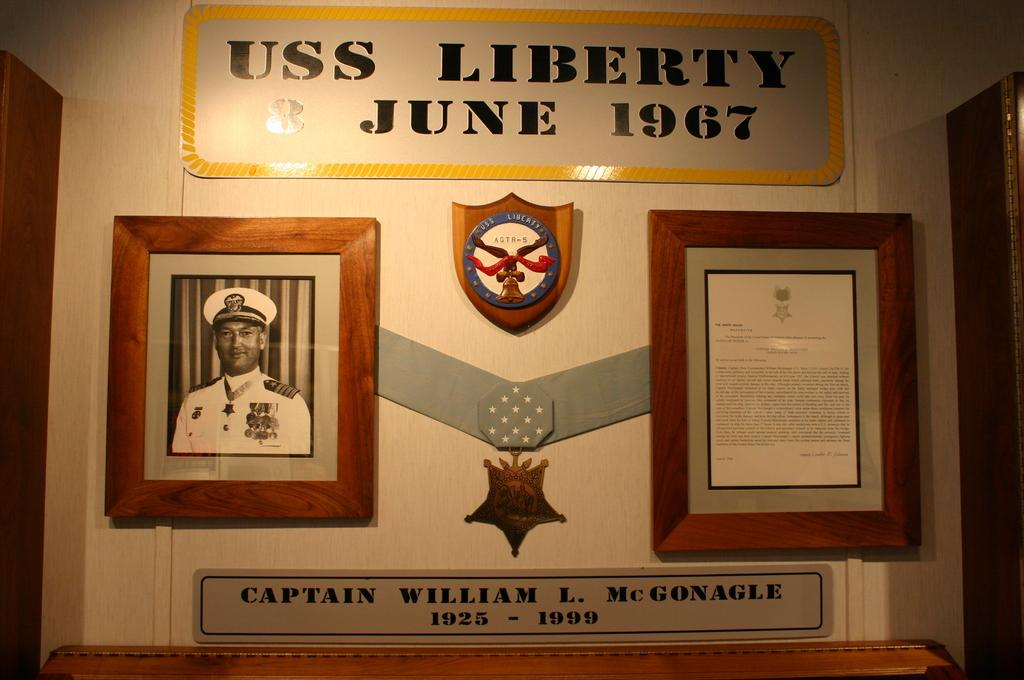<image>
Describe the image concisely. A dedication wall has been made for Captain William L McGonagle who served on the USS Liberty in 1967 